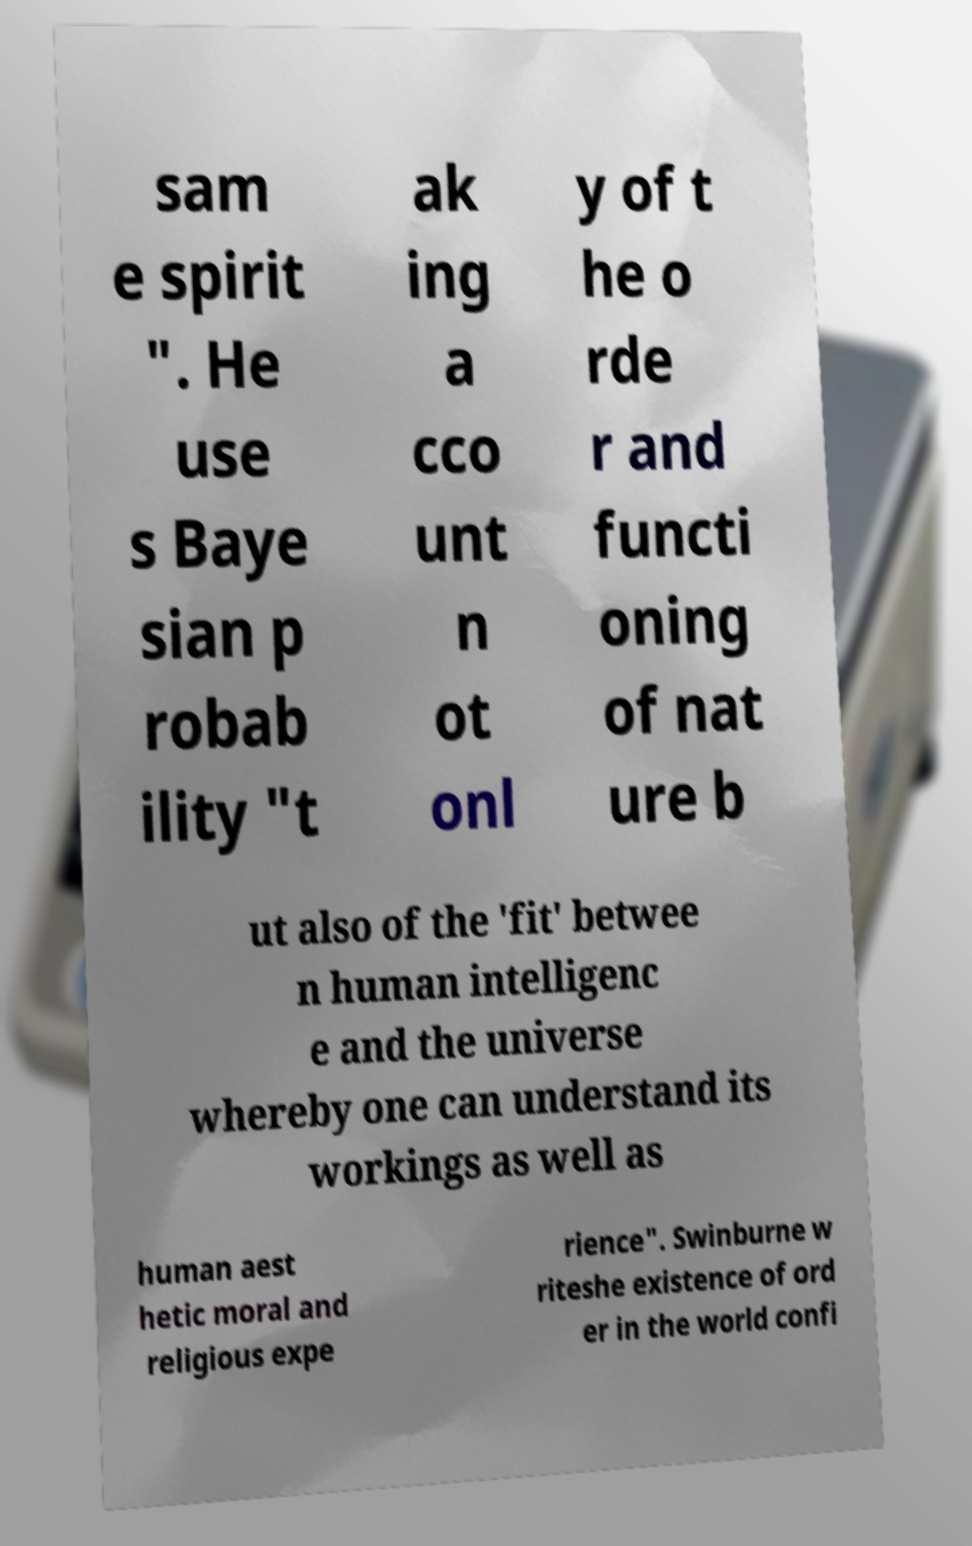Can you accurately transcribe the text from the provided image for me? sam e spirit ". He use s Baye sian p robab ility "t ak ing a cco unt n ot onl y of t he o rde r and functi oning of nat ure b ut also of the 'fit' betwee n human intelligenc e and the universe whereby one can understand its workings as well as human aest hetic moral and religious expe rience". Swinburne w riteshe existence of ord er in the world confi 